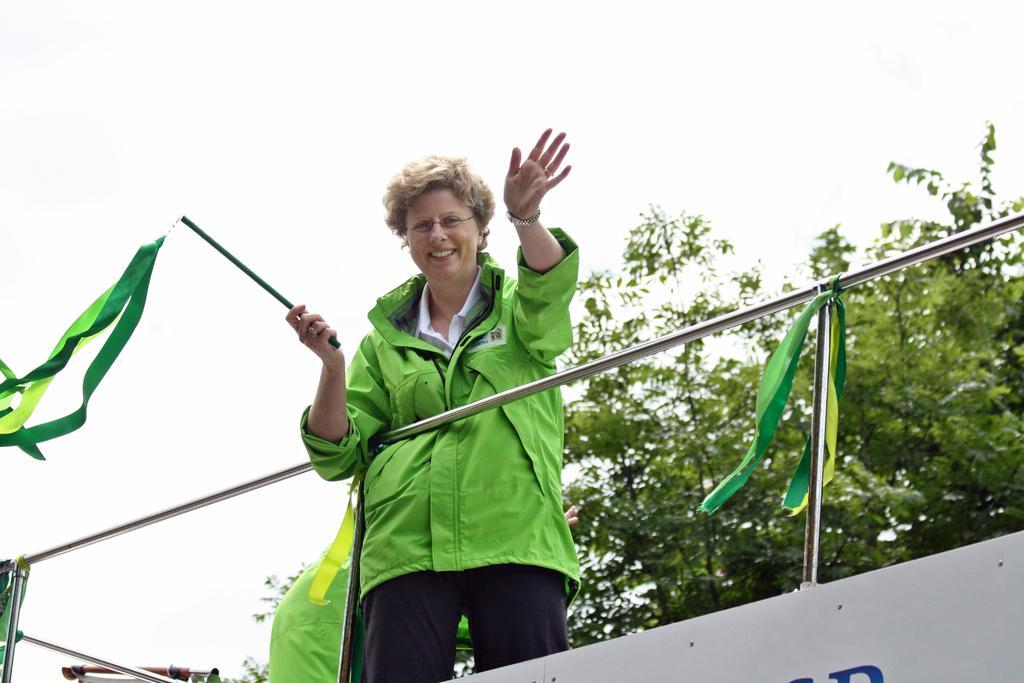Can you describe this image briefly? In the center of the image there is a woman standing and holding stick and ribbons. At the bottom of the image we can see ribbons. In the background we can see trees and sky. 